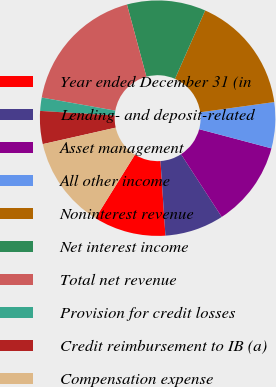Convert chart. <chart><loc_0><loc_0><loc_500><loc_500><pie_chart><fcel>Year ended December 31 (in<fcel>Lending- and deposit-related<fcel>Asset management<fcel>All other income<fcel>Noninterest revenue<fcel>Net interest income<fcel>Total net revenue<fcel>Provision for credit losses<fcel>Credit reimbursement to IB (a)<fcel>Compensation expense<nl><fcel>9.91%<fcel>8.11%<fcel>11.71%<fcel>6.31%<fcel>16.2%<fcel>10.81%<fcel>18.0%<fcel>1.82%<fcel>4.52%<fcel>12.61%<nl></chart> 